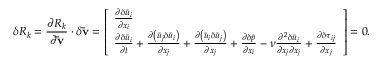<formula> <loc_0><loc_0><loc_500><loc_500>\delta R _ { k } = \frac { { \partial { R _ { k } } } } { { \partial { \bar { v } } } } \cdot \delta { \bar { v } } = \left [ \begin{array} { l } { \frac { { \partial \delta { { \bar { u } } _ { i } } } } { { \partial { x _ { i } } } } } \\ { \frac { { \partial \delta { { \bar { u } } _ { i } } } } { \partial t } + \frac { { \partial \left ( { { { \bar { u } } _ { j } } \delta { { \bar { u } } _ { i } } } \right ) } } { { \partial { x _ { j } } } } + \frac { { \partial \left ( { { { \bar { u } } _ { i } } \delta { { \bar { u } } _ { j } } } \right ) } } { { \partial { x _ { j } } } } + \frac { { \partial \delta \bar { p } } } { { \partial { x _ { i } } } } - \nu \frac { { { \partial ^ { 2 } } \delta { { \bar { u } } _ { i } } } } { { \partial { x _ { j } } \partial { x _ { j } } } } + \frac { \partial \delta { \tau _ { i j } } } { { \partial { x _ { j } } } } } \end{array} \right ] = 0 .</formula> 